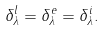<formula> <loc_0><loc_0><loc_500><loc_500>\delta _ { \lambda } ^ { l } = \delta _ { \lambda } ^ { e } = \delta _ { \lambda } ^ { i } .</formula> 